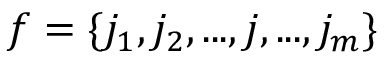Convert formula to latex. <formula><loc_0><loc_0><loc_500><loc_500>f = \{ j _ { 1 } , j _ { 2 } , \dots , j , \dots , j _ { m } \}</formula> 